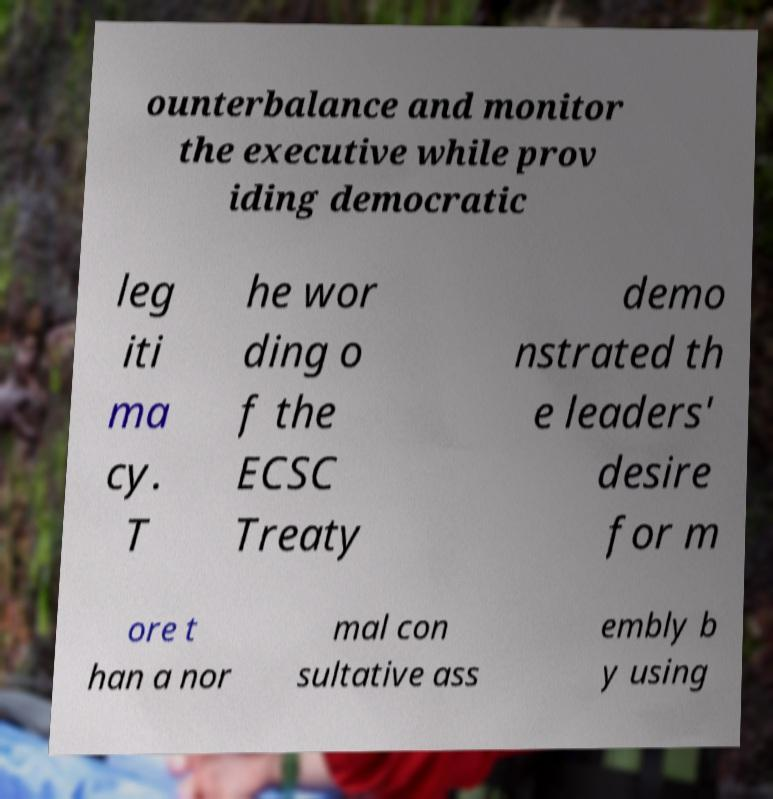There's text embedded in this image that I need extracted. Can you transcribe it verbatim? ounterbalance and monitor the executive while prov iding democratic leg iti ma cy. T he wor ding o f the ECSC Treaty demo nstrated th e leaders' desire for m ore t han a nor mal con sultative ass embly b y using 